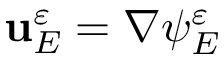<formula> <loc_0><loc_0><loc_500><loc_500>u _ { E } ^ { \varepsilon } = \nabla \psi _ { E } ^ { \varepsilon }</formula> 